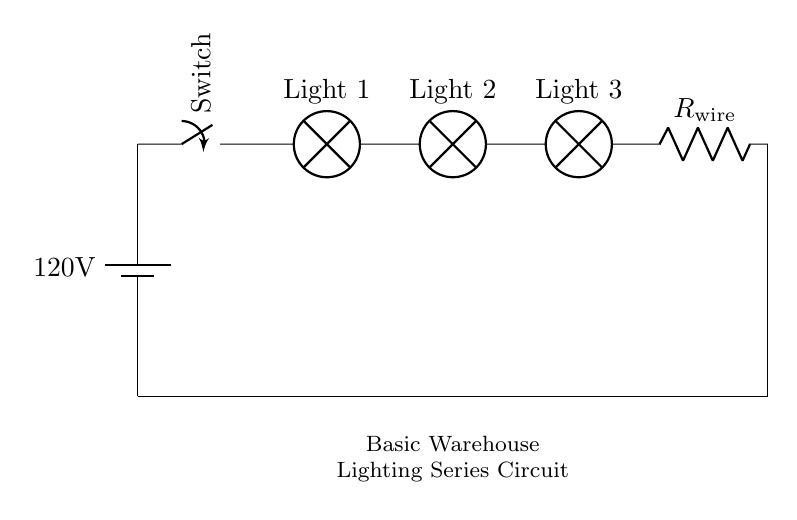what is the voltage of this circuit? The voltage of the circuit is 120 volts, which is provided by the battery as indicated in the circuit diagram.
Answer: 120 volts what components are in this circuit? The circuit includes a battery, a switch, three lamps, and a resistor representing wiring resistance. Each component is labeled in the diagram, making them easy to identify.
Answer: battery, switch, lamps, resistor how many lights are there in the circuit? There are three lights in the circuit, as indicated by the three lamp symbols drawn in series between the battery and the resistor.
Answer: three what happens if one lamp fails in this series circuit? If one lamp fails in a series circuit, the entire circuit stops functioning because the current can no longer flow. This is a defining characteristic of series circuits; all components must be operational for the circuit to work.
Answer: whole circuit fails what is the purpose of the resistor labeled R_wire? The resistor labeled R_wire represents the resistance due to the wiring in the circuit. It indicates that there is some energy loss or voltage drop in the wires, which is essential for understanding the overall behavior and efficiency of the circuit.
Answer: wiring resistance what is the current flow direction in this circuit? The current flows from the positive terminal of the battery, through the switch, then through the lamps in series, and finally through the resistor before returning to the battery's negative terminal. This is the conventional current flow direction.
Answer: from battery to switch to lamps to resistor how does adding more lamps affect the total resistance? Adding more lamps in series increases the total resistance of the circuit because resistances in series add up. Each lamp introduces its own resistance, and the total resistance is the sum of the individual resistances. This affects the current flowing through the circuit according to Ohm's law.
Answer: increases total resistance 